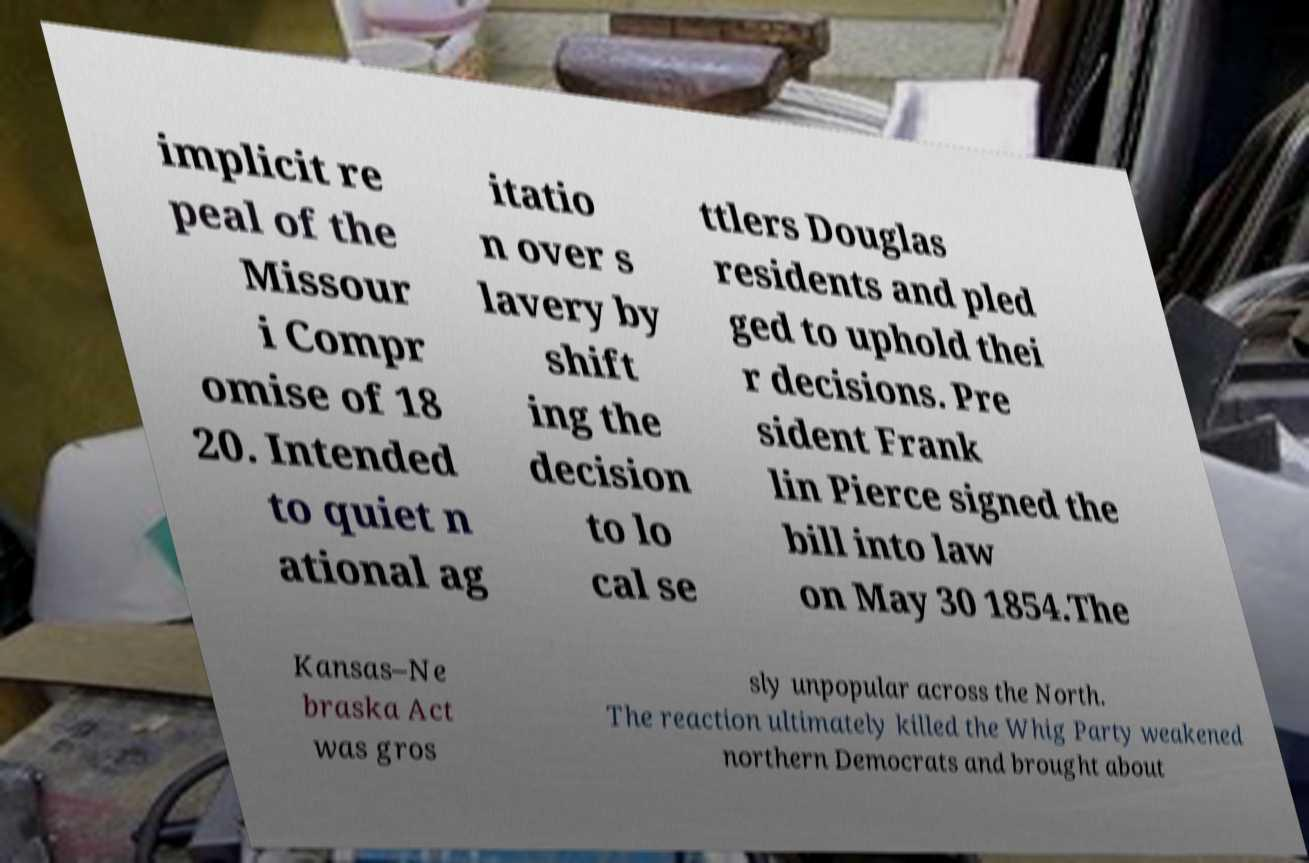I need the written content from this picture converted into text. Can you do that? implicit re peal of the Missour i Compr omise of 18 20. Intended to quiet n ational ag itatio n over s lavery by shift ing the decision to lo cal se ttlers Douglas residents and pled ged to uphold thei r decisions. Pre sident Frank lin Pierce signed the bill into law on May 30 1854.The Kansas–Ne braska Act was gros sly unpopular across the North. The reaction ultimately killed the Whig Party weakened northern Democrats and brought about 